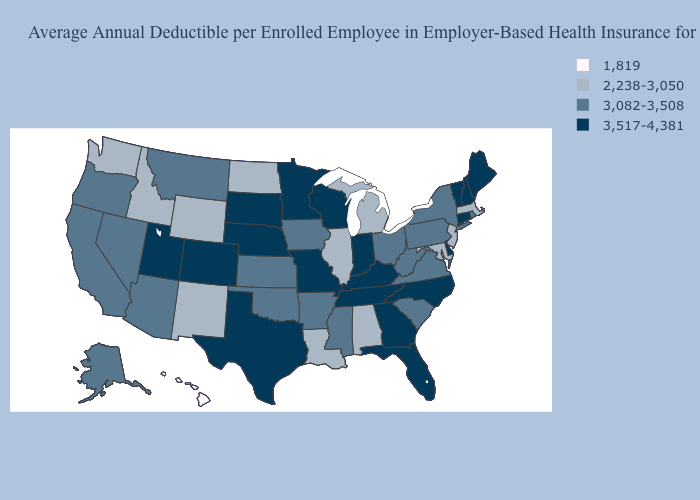What is the value of Arizona?
Short answer required. 3,082-3,508. Among the states that border Louisiana , does Texas have the highest value?
Answer briefly. Yes. Does Hawaii have the lowest value in the USA?
Keep it brief. Yes. How many symbols are there in the legend?
Short answer required. 4. Among the states that border New Jersey , which have the highest value?
Answer briefly. Delaware. Name the states that have a value in the range 1,819?
Be succinct. Hawaii. Does Hawaii have the lowest value in the USA?
Concise answer only. Yes. Name the states that have a value in the range 3,517-4,381?
Keep it brief. Colorado, Connecticut, Delaware, Florida, Georgia, Indiana, Kentucky, Maine, Minnesota, Missouri, Nebraska, New Hampshire, North Carolina, South Dakota, Tennessee, Texas, Utah, Vermont, Wisconsin. Which states have the highest value in the USA?
Quick response, please. Colorado, Connecticut, Delaware, Florida, Georgia, Indiana, Kentucky, Maine, Minnesota, Missouri, Nebraska, New Hampshire, North Carolina, South Dakota, Tennessee, Texas, Utah, Vermont, Wisconsin. What is the highest value in states that border Tennessee?
Concise answer only. 3,517-4,381. How many symbols are there in the legend?
Give a very brief answer. 4. Name the states that have a value in the range 2,238-3,050?
Keep it brief. Alabama, Idaho, Illinois, Louisiana, Maryland, Massachusetts, Michigan, New Jersey, New Mexico, North Dakota, Washington, Wyoming. Name the states that have a value in the range 1,819?
Keep it brief. Hawaii. Does Illinois have the lowest value in the MidWest?
Answer briefly. Yes. Does Wisconsin have a lower value than New Hampshire?
Keep it brief. No. 